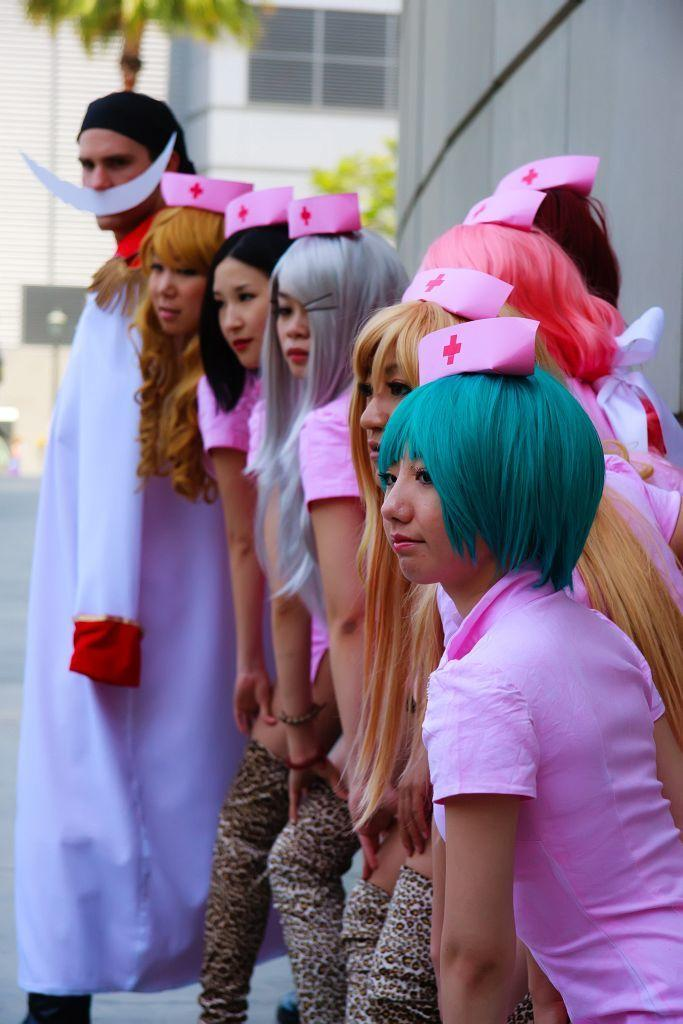What are the people in the image wearing on their heads? The people in the image are wearing caps. What can be seen behind the people in the image? There is a wall visible in the image, and in the background, there is a window, a board, and trees. Where is the nest located in the image? There is no nest present in the image. How many houses can be seen in the image? There is no house present in the image; only a wall, window, board, and trees are visible in the background. 